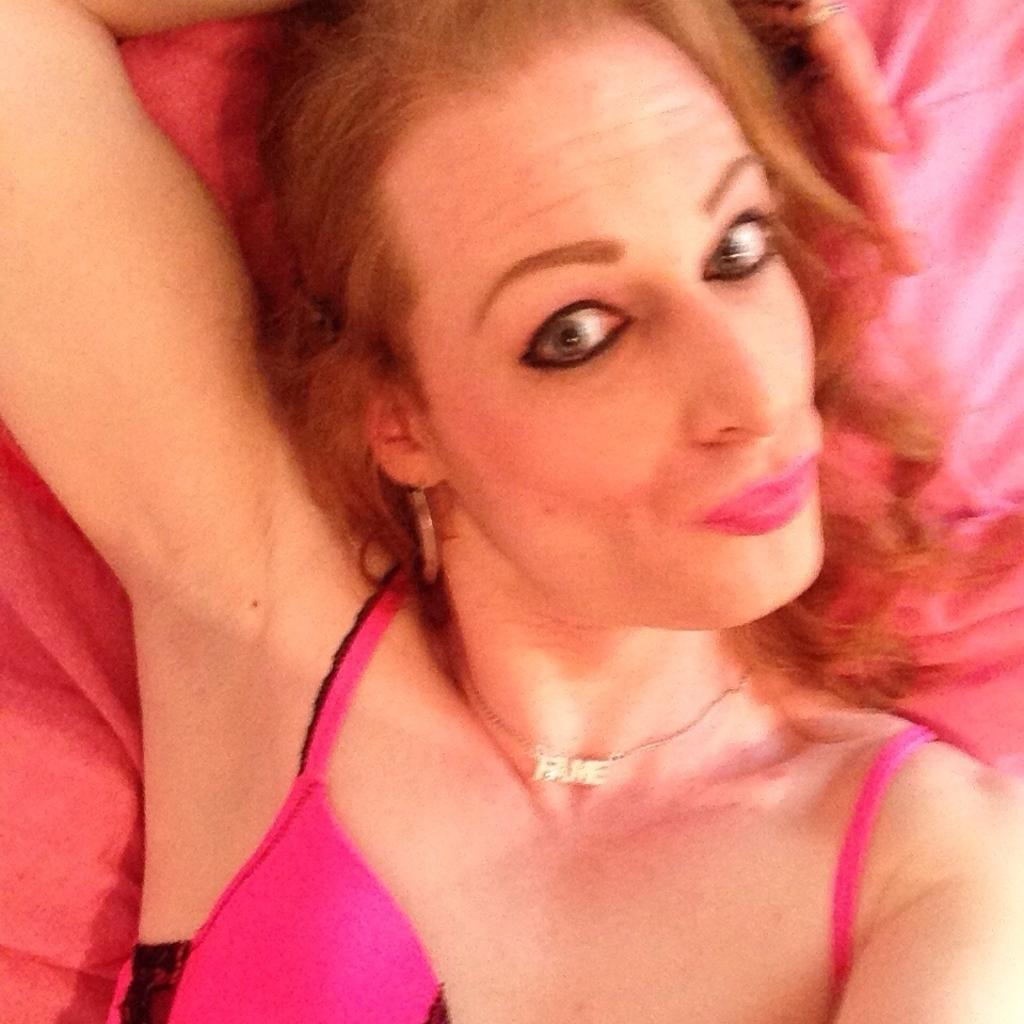Who is present in the image? There is a woman in the image. What is the woman doing in the image? The woman is lying on a bed. What type of oil can be seen dripping from the woman's hair in the image? There is no oil or any dripping substance visible in the woman's hair in the image. 